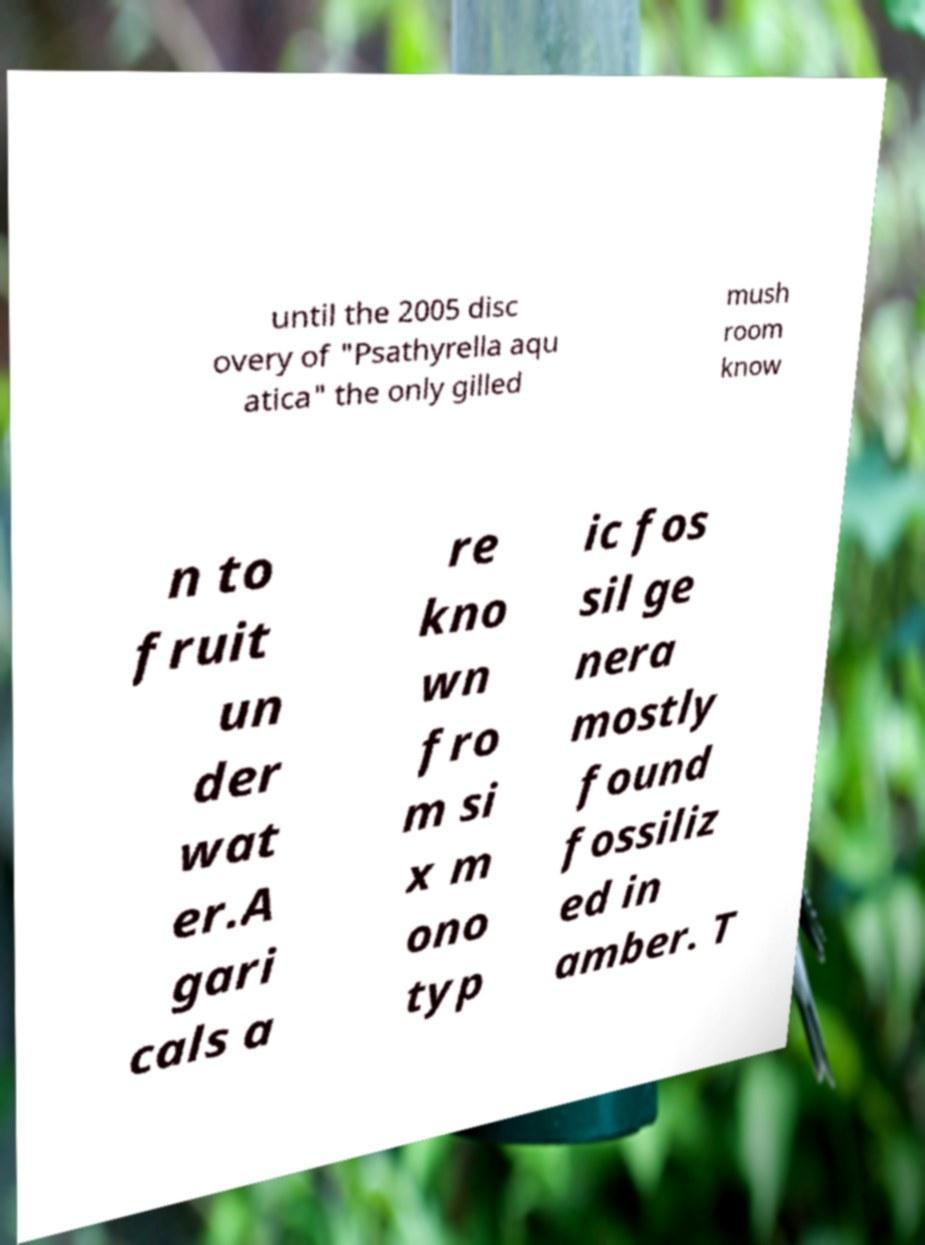For documentation purposes, I need the text within this image transcribed. Could you provide that? until the 2005 disc overy of "Psathyrella aqu atica" the only gilled mush room know n to fruit un der wat er.A gari cals a re kno wn fro m si x m ono typ ic fos sil ge nera mostly found fossiliz ed in amber. T 